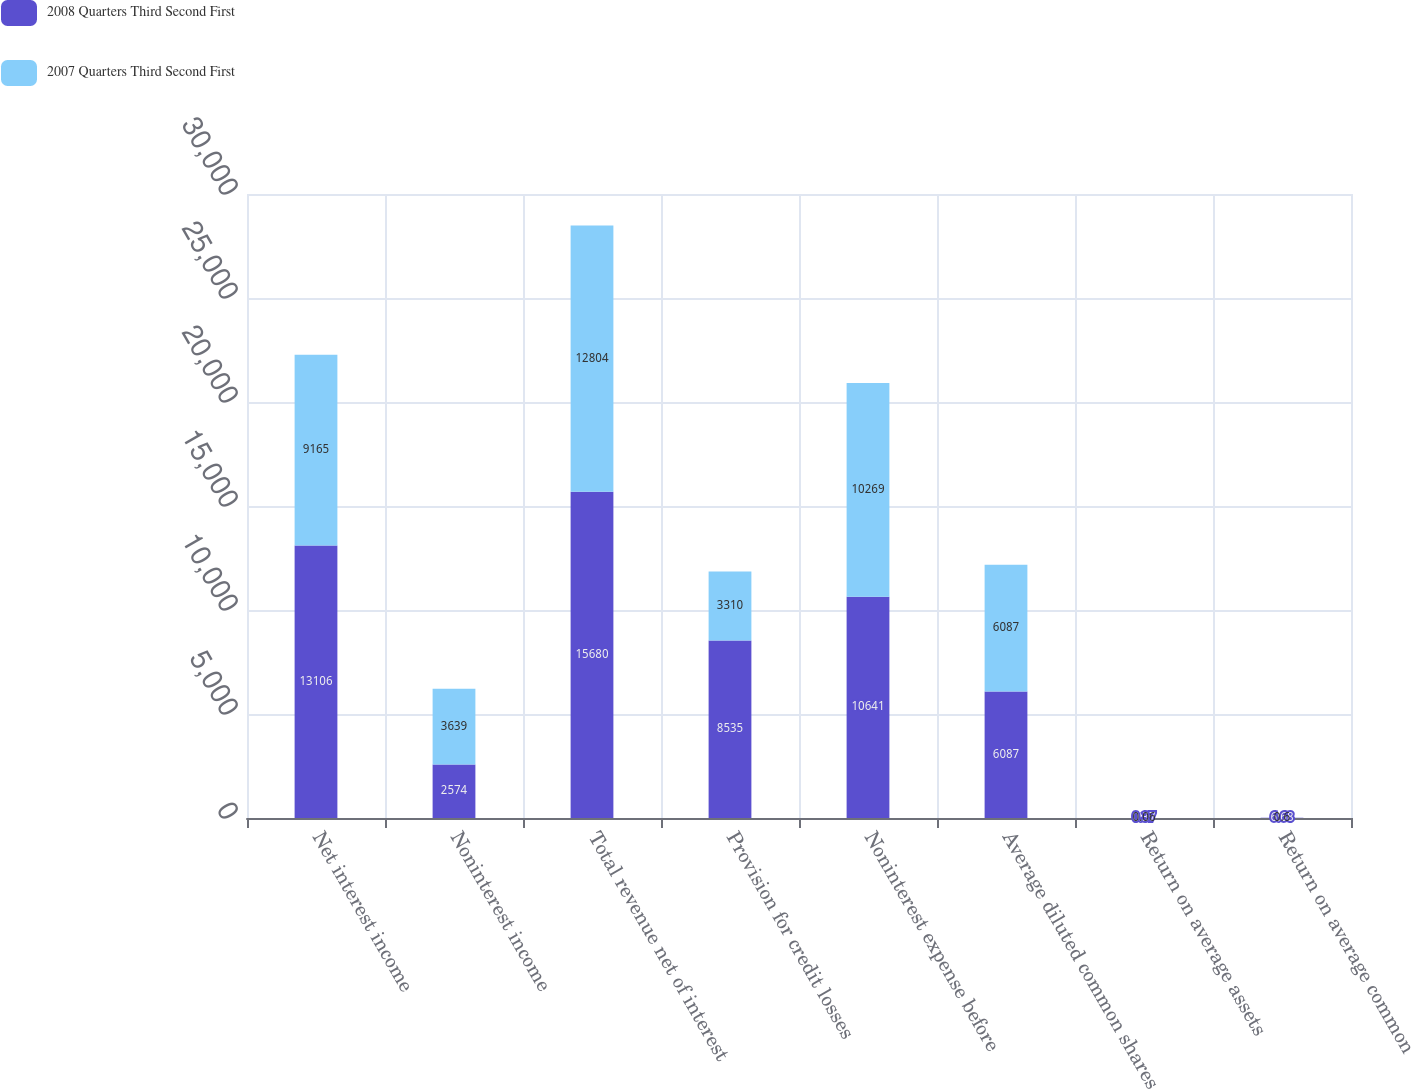<chart> <loc_0><loc_0><loc_500><loc_500><stacked_bar_chart><ecel><fcel>Net interest income<fcel>Noninterest income<fcel>Total revenue net of interest<fcel>Provision for credit losses<fcel>Noninterest expense before<fcel>Average diluted common shares<fcel>Return on average assets<fcel>Return on average common<nl><fcel>2008 Quarters Third Second First<fcel>13106<fcel>2574<fcel>15680<fcel>8535<fcel>10641<fcel>6087<fcel>0.37<fcel>6.68<nl><fcel>2007 Quarters Third Second First<fcel>9165<fcel>3639<fcel>12804<fcel>3310<fcel>10269<fcel>6087<fcel>0.06<fcel>0.6<nl></chart> 